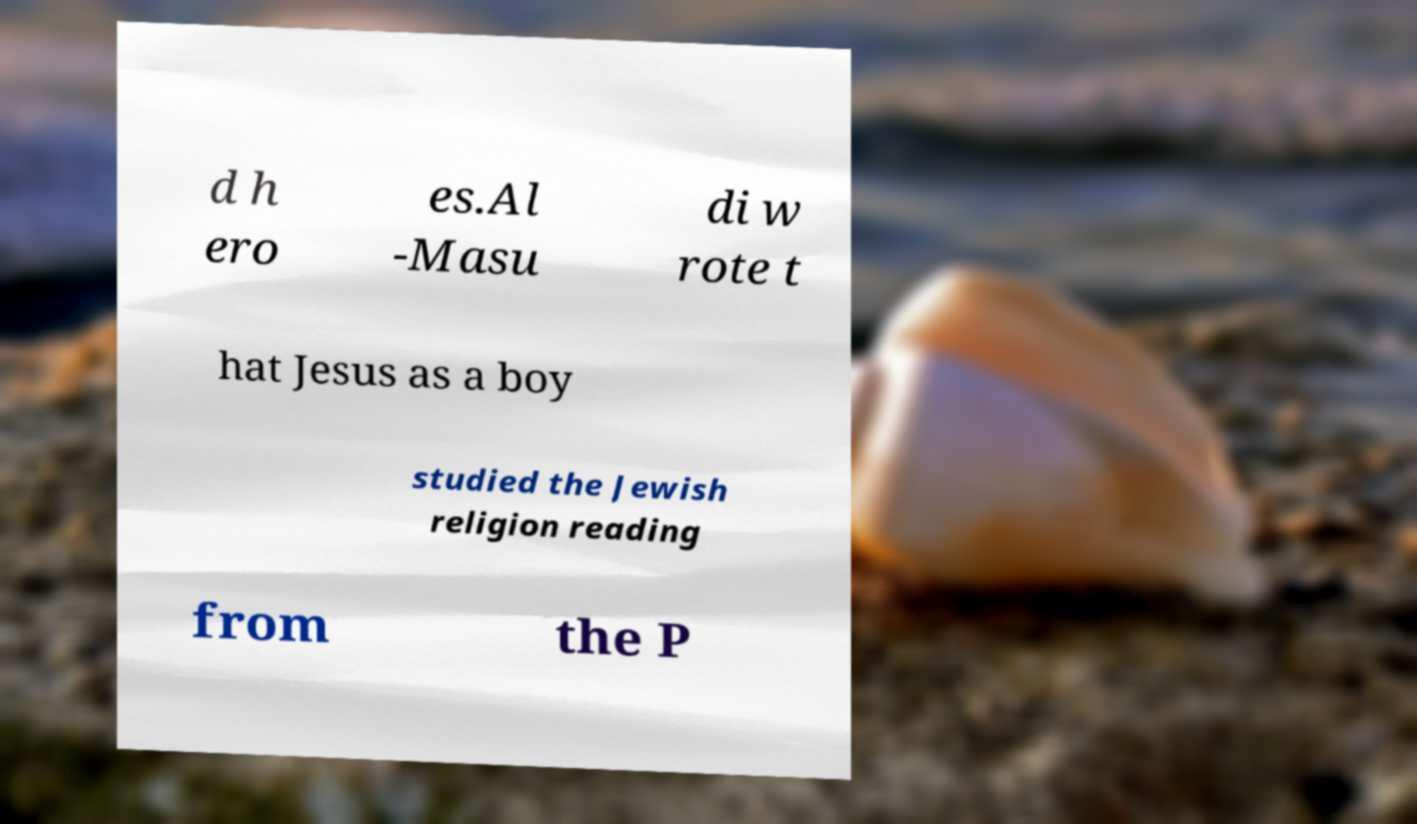Could you assist in decoding the text presented in this image and type it out clearly? d h ero es.Al -Masu di w rote t hat Jesus as a boy studied the Jewish religion reading from the P 